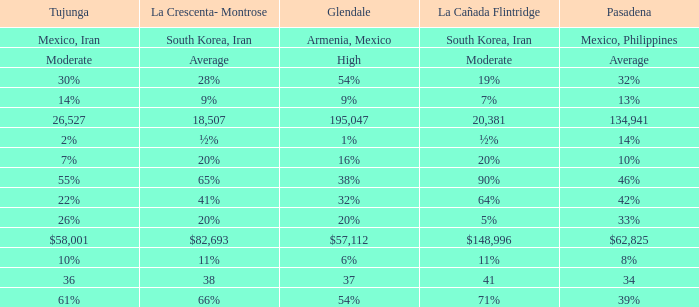What is the figure for La Canada Flintridge when Pasadena is 34? 41.0. 